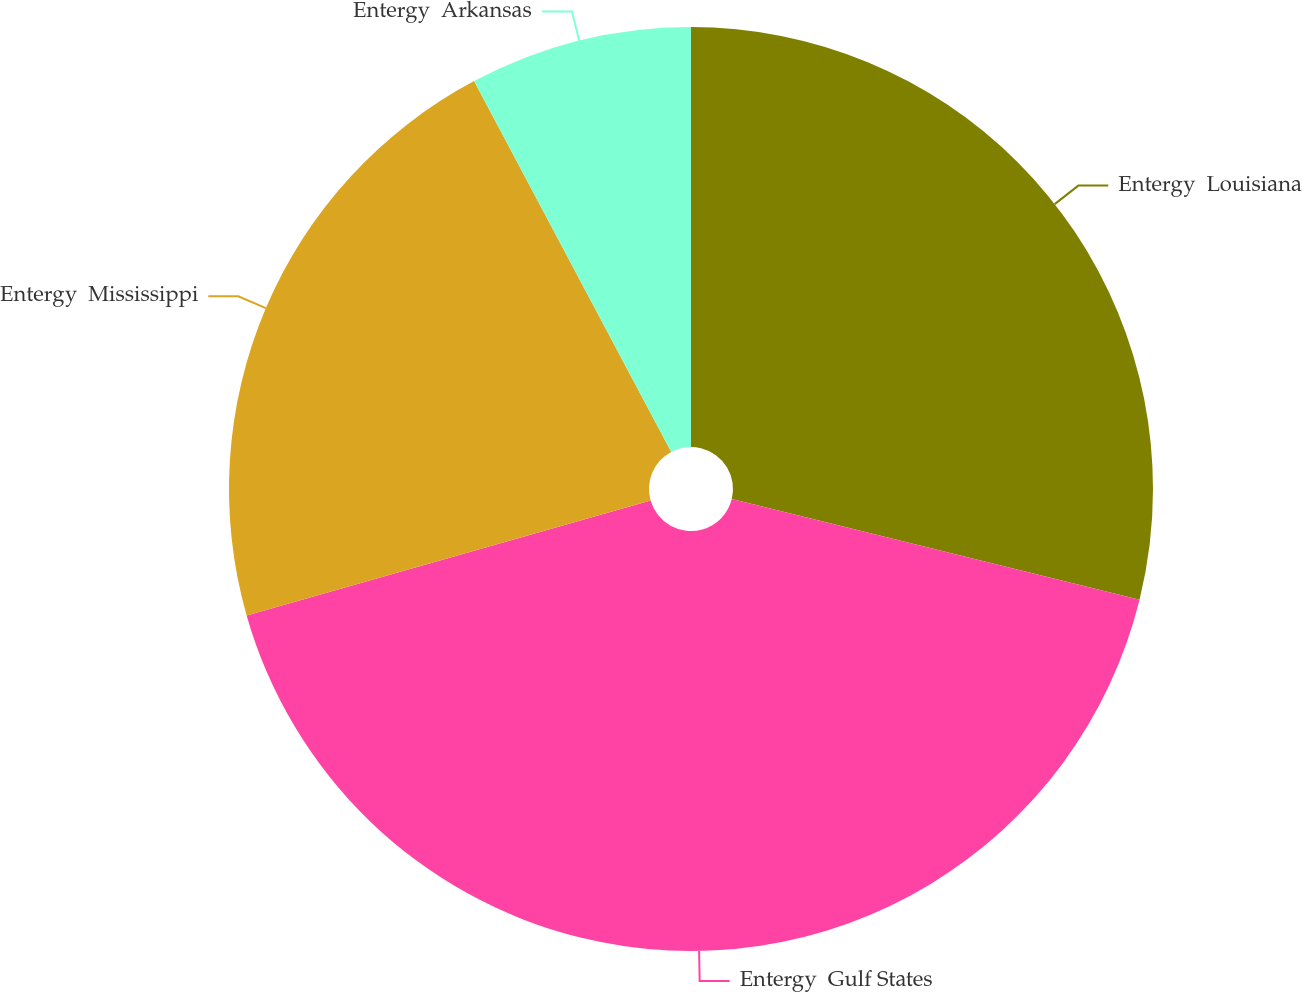Convert chart to OTSL. <chart><loc_0><loc_0><loc_500><loc_500><pie_chart><fcel>Entergy  Louisiana<fcel>Entergy  Gulf States<fcel>Entergy  Mississippi<fcel>Entergy  Arkansas<nl><fcel>28.85%<fcel>41.74%<fcel>21.63%<fcel>7.78%<nl></chart> 